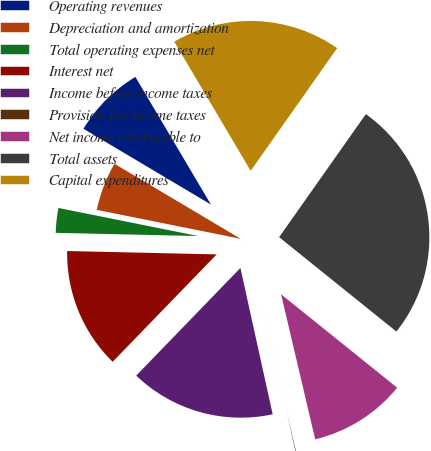<chart> <loc_0><loc_0><loc_500><loc_500><pie_chart><fcel>Operating revenues<fcel>Depreciation and amortization<fcel>Total operating expenses net<fcel>Interest net<fcel>Income before income taxes<fcel>Provision for income taxes<fcel>Net income attributable to<fcel>Total assets<fcel>Capital expenditures<nl><fcel>7.96%<fcel>5.38%<fcel>2.8%<fcel>13.12%<fcel>15.7%<fcel>0.22%<fcel>10.54%<fcel>26.02%<fcel>18.28%<nl></chart> 